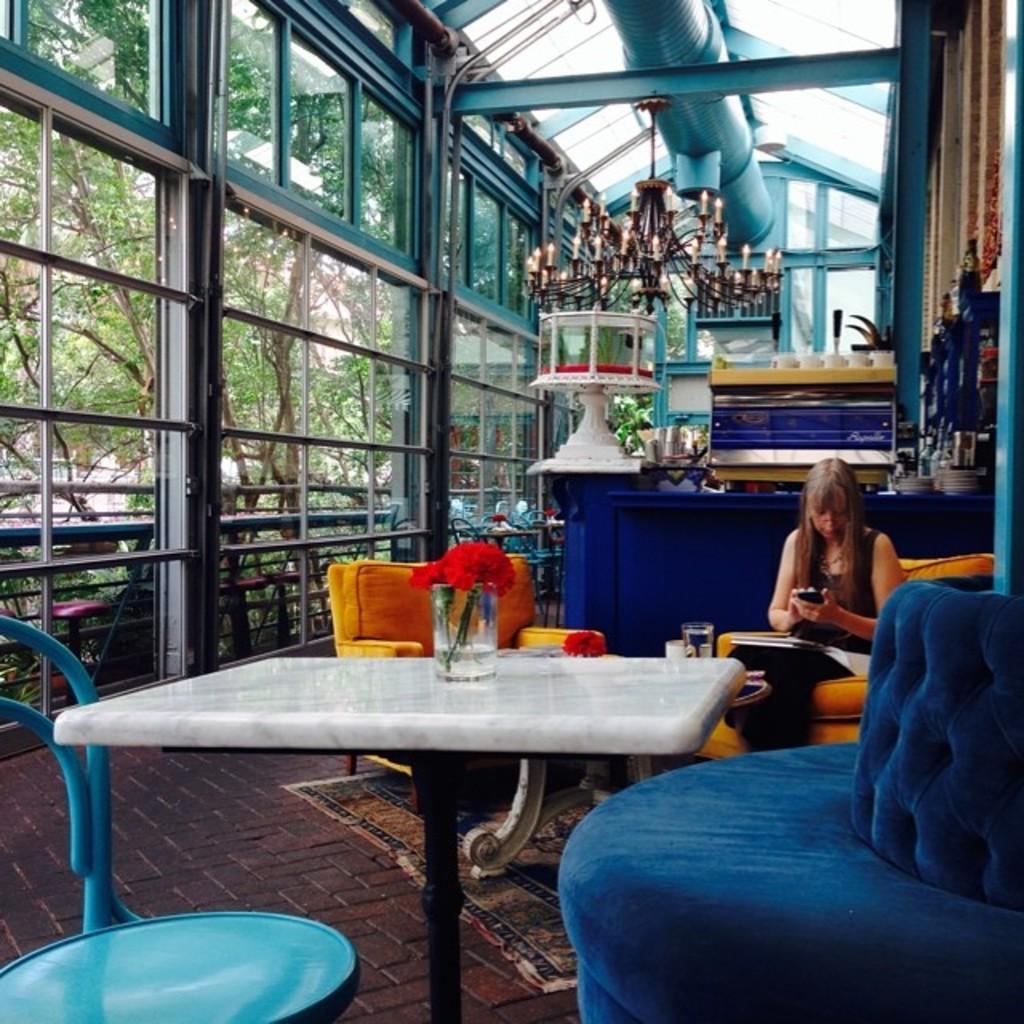How would you summarize this image in a sentence or two? In the image we can see there is a woman who is sitting on chair and in front of her there is a table and the glass on which flowers are kept. 